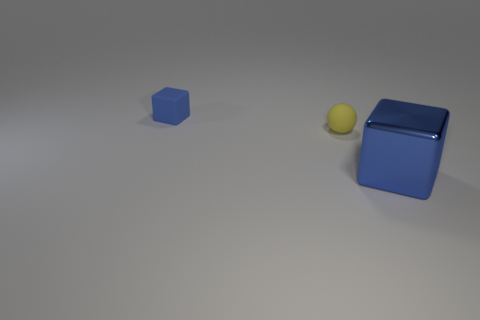Subtract all brown balls. Subtract all red cubes. How many balls are left? 1 Add 3 big green rubber objects. How many objects exist? 6 Subtract all cubes. How many objects are left? 1 Add 3 blocks. How many blocks exist? 5 Subtract 0 brown cylinders. How many objects are left? 3 Subtract all tiny yellow things. Subtract all blue shiny blocks. How many objects are left? 1 Add 3 tiny matte things. How many tiny matte things are left? 5 